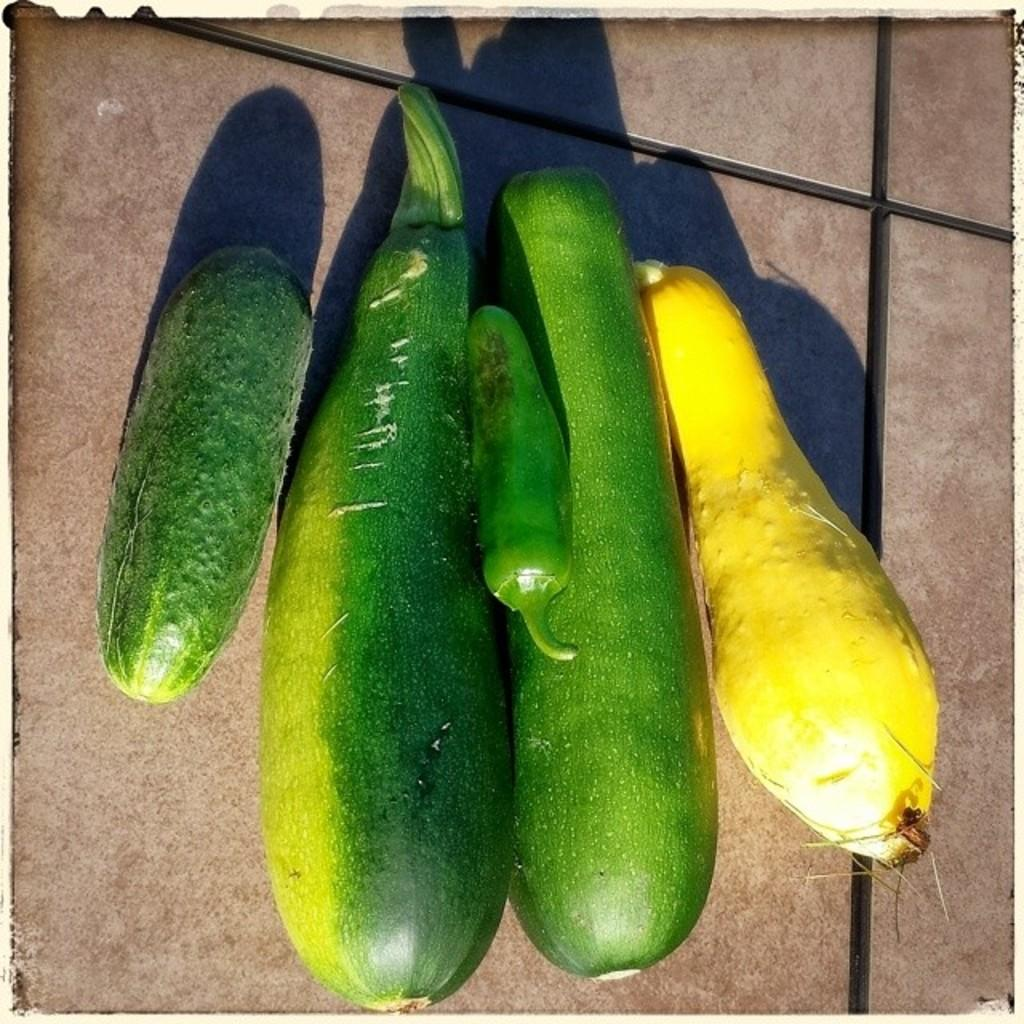What is the main subject of the image? The main subject of the image is different types of vegetables. Where are the vegetables located in the image? The vegetables are in the center of the image. What can be seen in the background of the image? There is a floor visible in the background of the image. What type of gold jewelry is being processed in the image? There is no gold jewelry or any process visible in the image; it features different types of vegetables in the center and a floor in the background. 